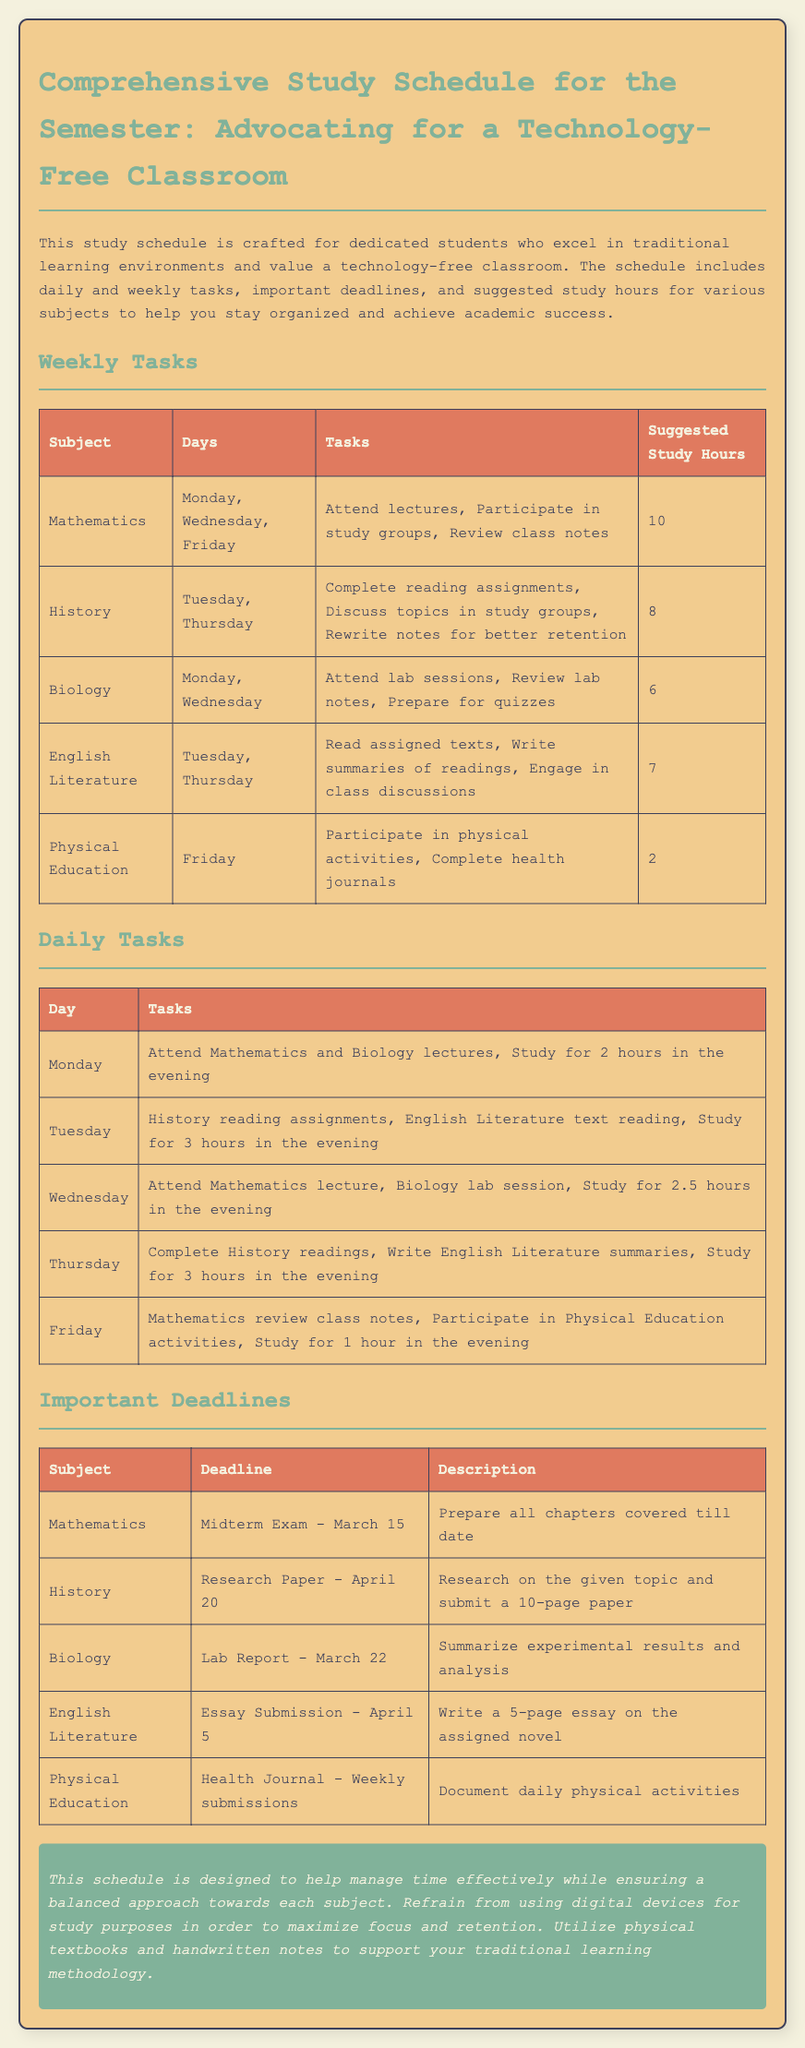What are the suggested study hours for Mathematics? The suggested study hours for Mathematics are specified in the Weekly Tasks section of the document.
Answer: 10 When is the deadline for the English Literature essay submission? The deadline for the English Literature essay is mentioned in the Important Deadlines section of the document.
Answer: April 5 Which day is designated for Physical Education tasks? The day designated for Physical Education tasks can be found in the Weekly Tasks section.
Answer: Friday What tasks are included for Biology in the weekly tasks? The tasks for Biology are listed in the Weekly Tasks section and can be found there.
Answer: Attend lab sessions, Review lab notes, Prepare for quizzes How many subjects have tasks listed for Tuesday? The number of subjects with tasks on Tuesday can be determined by checking the Daily Tasks section of the document.
Answer: 2 What is the total suggested study hours for English Literature? The total suggested study hours for English Literature can be found in the Weekly Tasks section of the document.
Answer: 7 What is the primary purpose of this study schedule? The primary purpose of the study schedule is described in the introduction of the document.
Answer: Help manage time effectively What type of learning methodology does the document advocate for? The document explicitly states its advocacy for a specific learning methodology within the introduction.
Answer: Traditional learning 